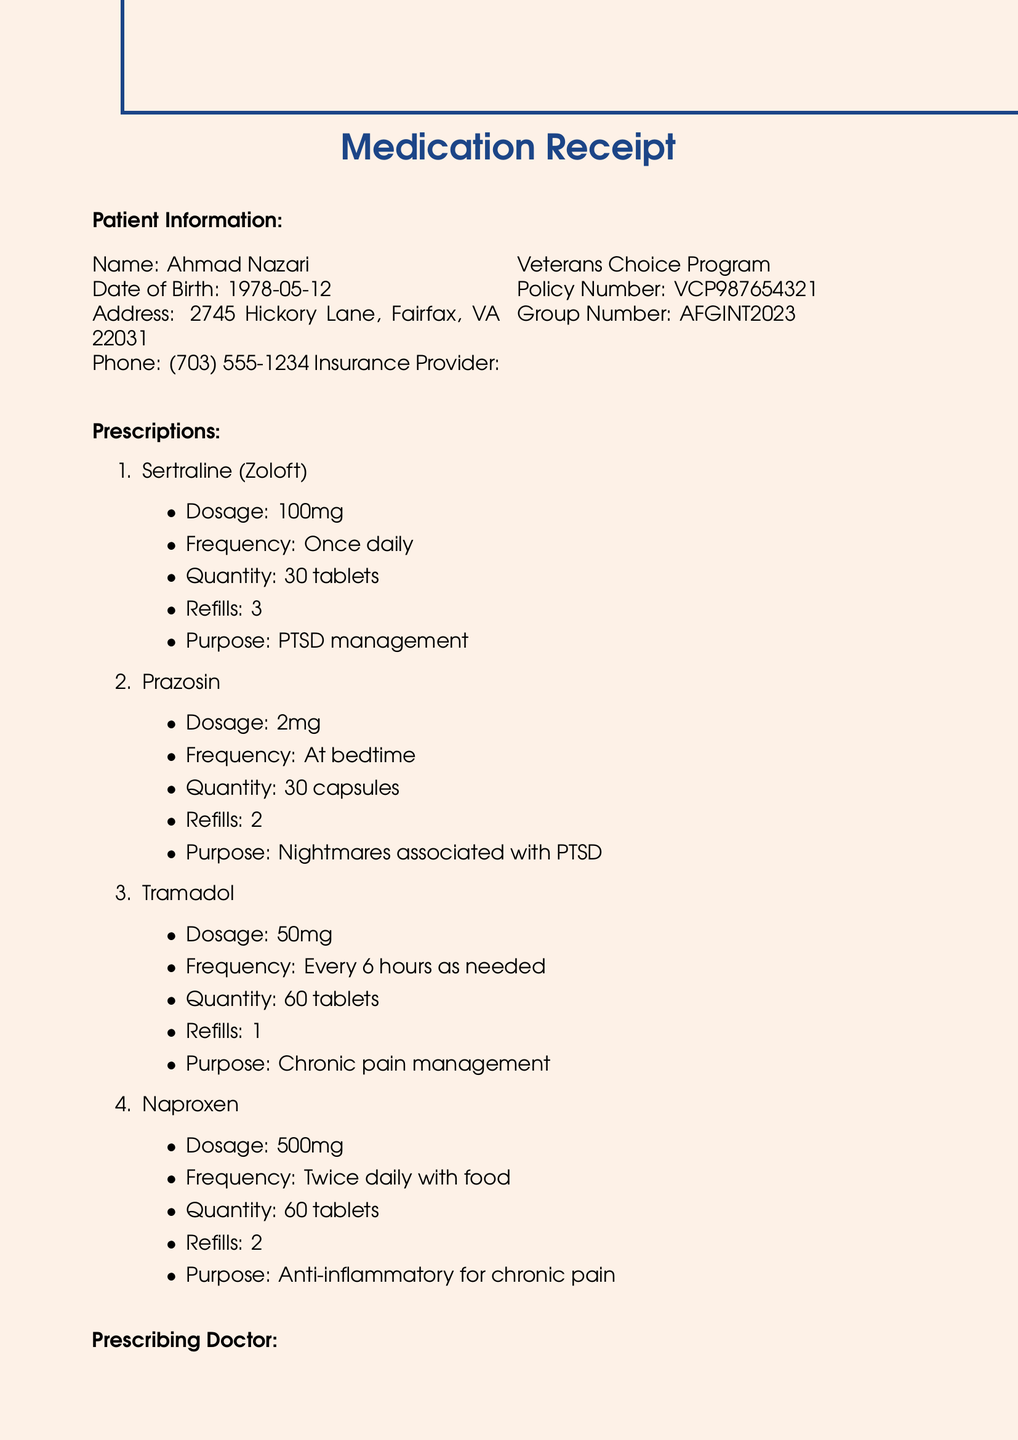What is the patient's name? The patient's name is mentioned in the document.
Answer: Ahmad Nazari What medication is prescribed for PTSD management? The document lists the purpose of each medication, including which one is for PTSD management.
Answer: Sertraline (Zoloft) How many refills are allowed for Tramadol? The total number of refills for Tramadol is clearly stated in the prescription details.
Answer: 1 Who is the prescribing doctor? The name of the prescribing doctor is provided in the doctor information section.
Answer: Dr. Sarah Thompson What is the dosage of Prazosin? The dosage is listed with each medication prescribed in the document.
Answer: 2mg What type of insurance does the patient have? The insurance provider is specified in the document.
Answer: Veterans Choice Program How many capsules of Prazosin are prescribed? The document indicates the quantity of Prazosin prescribed.
Answer: 30 capsules Which pharmacy is mentioned in the document? The name of the pharmacy is stated in the prescription details section.
Answer: CVS Pharmacy What is the quantity of Naproxen prescribed? The quantity is included in the prescription details for Naproxen.
Answer: 60 tablets 